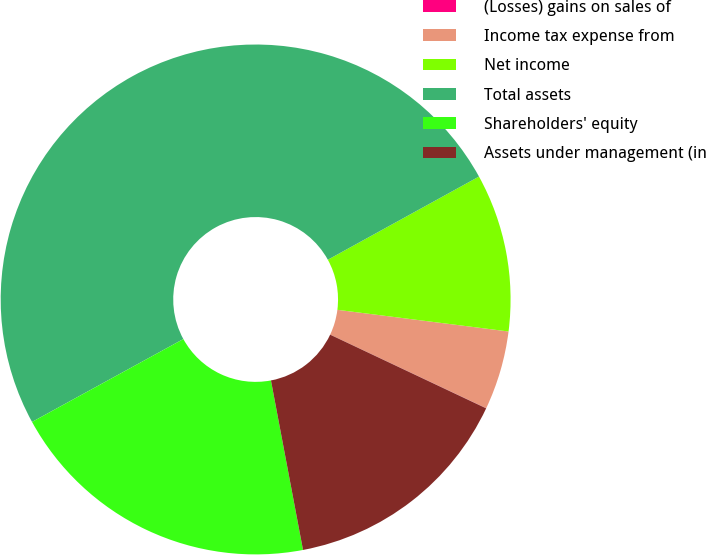<chart> <loc_0><loc_0><loc_500><loc_500><pie_chart><fcel>(Losses) gains on sales of<fcel>Income tax expense from<fcel>Net income<fcel>Total assets<fcel>Shareholders' equity<fcel>Assets under management (in<nl><fcel>0.01%<fcel>5.01%<fcel>10.01%<fcel>49.97%<fcel>20.0%<fcel>15.0%<nl></chart> 